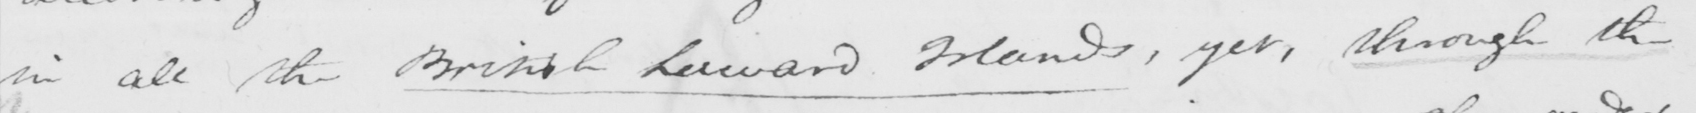Transcribe the text shown in this historical manuscript line. in all the British Leeward Islands , yet , through the 